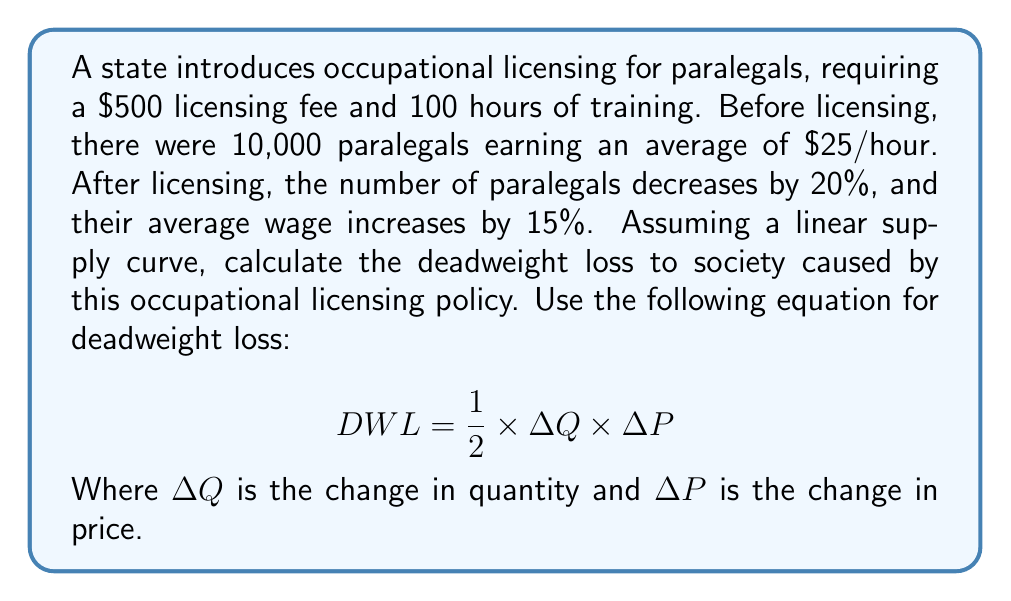Solve this math problem. To solve this problem, we'll follow these steps:

1. Calculate the change in quantity ($\Delta Q$):
   Initial quantity: 10,000
   New quantity: 10,000 × (1 - 0.20) = 8,000
   $\Delta Q = 10,000 - 8,000 = 2,000$ paralegals

2. Calculate the change in price ($\Delta P$):
   Initial wage: $25/hour
   New wage: $25 × (1 + 0.15) = $28.75/hour
   $\Delta P = $28.75 - $25 = $3.75/hour

3. Apply the deadweight loss formula:
   $$ DWL = \frac{1}{2} \times \Delta Q \times \Delta P $$
   $$ DWL = \frac{1}{2} \times 2,000 \times $3.75 $$
   $$ DWL = $3,750 \text{ per hour} $$

4. To get the annual deadweight loss, we need to multiply by the number of working hours in a year:
   Assuming 2,080 working hours per year (40 hours/week × 52 weeks):
   $$ \text{Annual DWL} = $3,750 \times 2,080 = $7,800,000 $$

Therefore, the deadweight loss to society caused by this occupational licensing policy is $7,800,000 per year.
Answer: $7,800,000 per year 